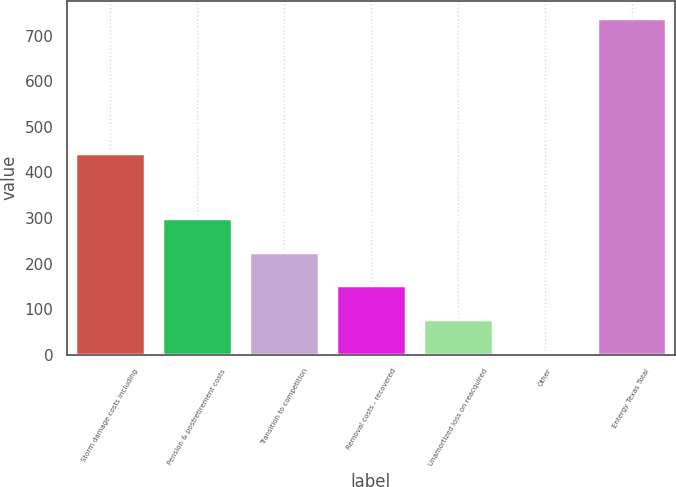Convert chart to OTSL. <chart><loc_0><loc_0><loc_500><loc_500><bar_chart><fcel>Storm damage costs including<fcel>Pension & postretirement costs<fcel>Transition to competition<fcel>Removal costs - recovered<fcel>Unamortized loss on reacquired<fcel>Other<fcel>Entergy Texas Total<nl><fcel>442.4<fcel>299.5<fcel>226.05<fcel>152.6<fcel>79.15<fcel>5.7<fcel>740.2<nl></chart> 